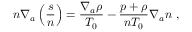<formula> <loc_0><loc_0><loc_500><loc_500>n \nabla _ { a } \left ( \frac { s } { n } \right ) = \frac { \nabla _ { a } \rho } { T _ { 0 } } - \frac { p + \rho } { n T _ { 0 } } \nabla _ { a } n ,</formula> 